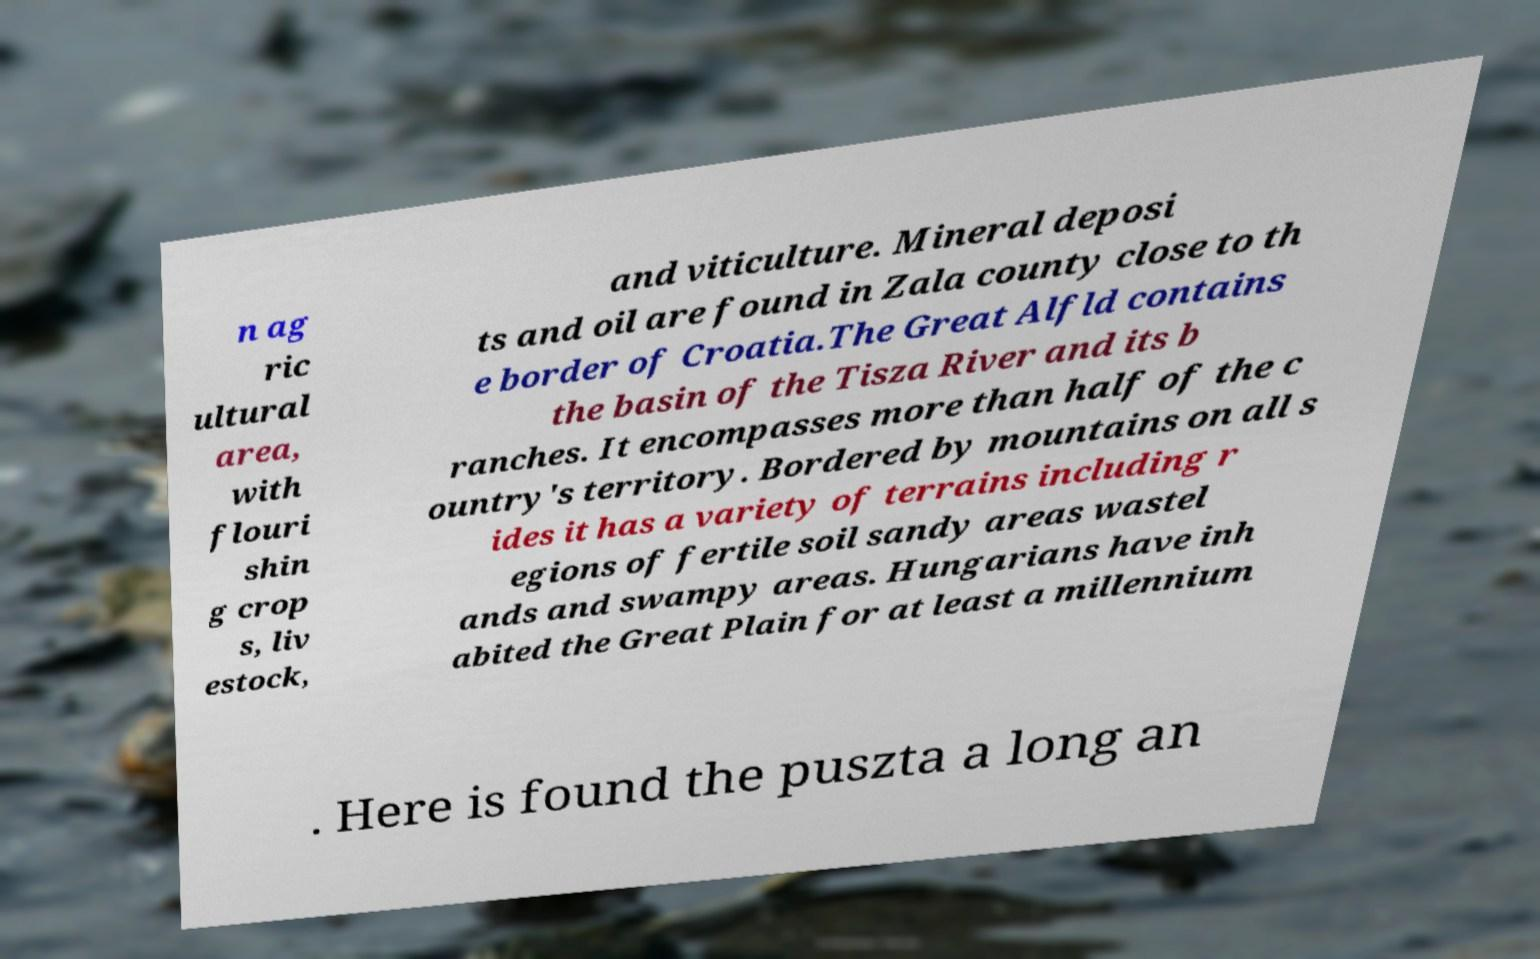Could you assist in decoding the text presented in this image and type it out clearly? n ag ric ultural area, with flouri shin g crop s, liv estock, and viticulture. Mineral deposi ts and oil are found in Zala county close to th e border of Croatia.The Great Alfld contains the basin of the Tisza River and its b ranches. It encompasses more than half of the c ountry's territory. Bordered by mountains on all s ides it has a variety of terrains including r egions of fertile soil sandy areas wastel ands and swampy areas. Hungarians have inh abited the Great Plain for at least a millennium . Here is found the puszta a long an 